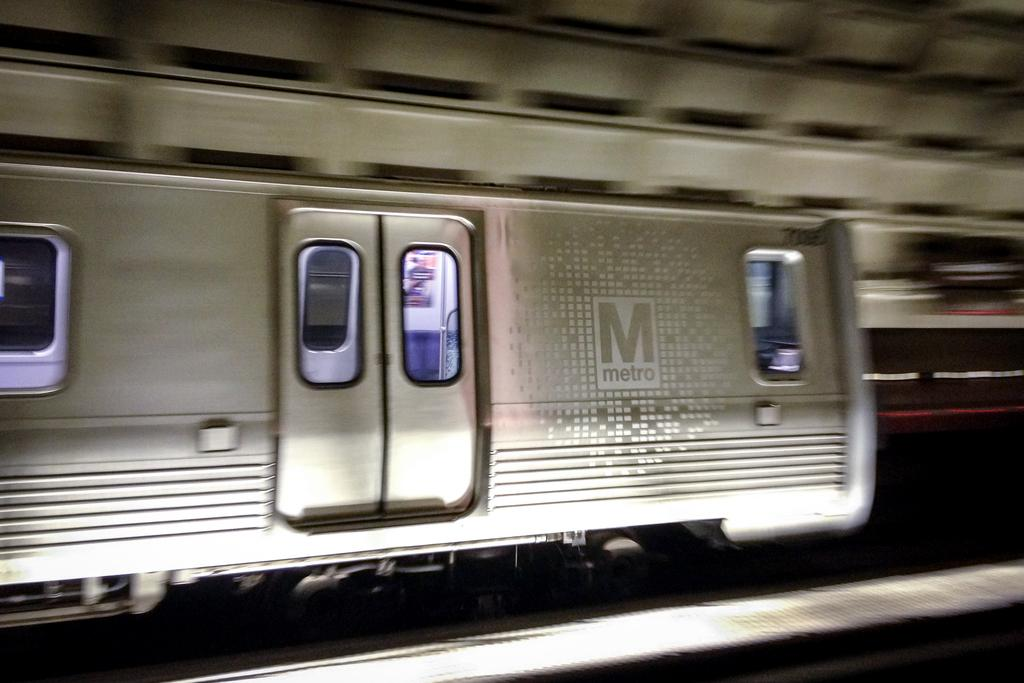<image>
Write a terse but informative summary of the picture. A subway car is in a station and has a metro logo on the side. 